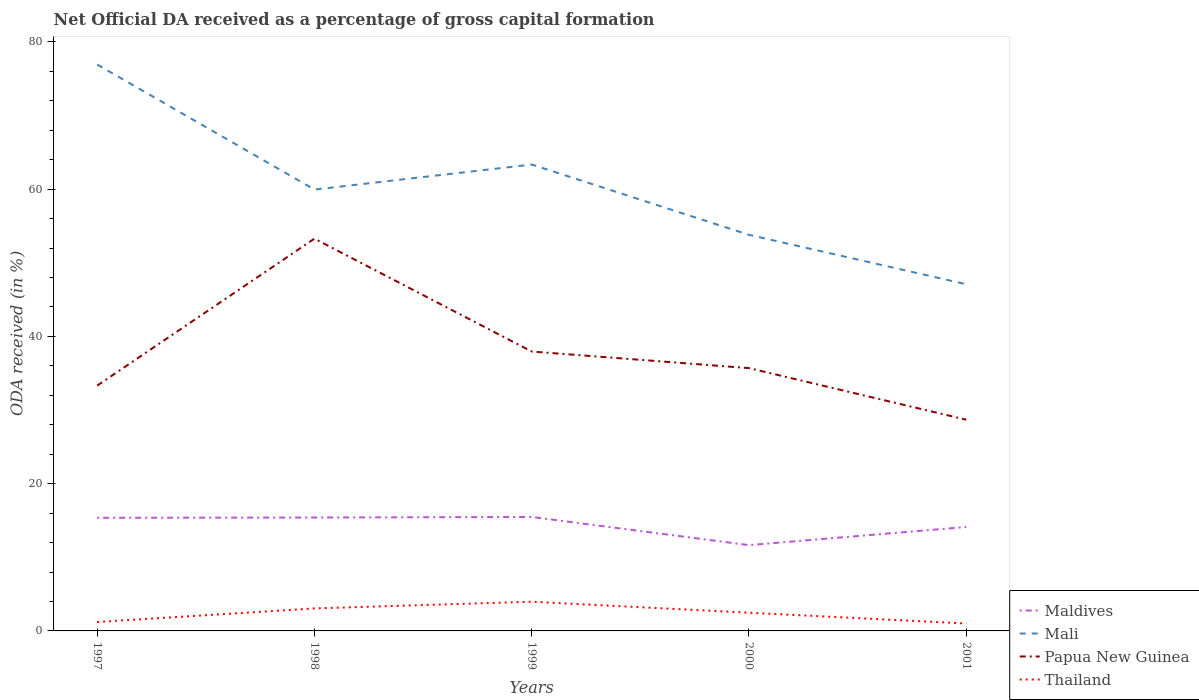Is the number of lines equal to the number of legend labels?
Give a very brief answer. Yes. Across all years, what is the maximum net ODA received in Papua New Guinea?
Your answer should be very brief. 28.69. In which year was the net ODA received in Thailand maximum?
Provide a short and direct response. 2001. What is the total net ODA received in Maldives in the graph?
Keep it short and to the point. -0.11. What is the difference between the highest and the second highest net ODA received in Thailand?
Offer a terse response. 2.96. What is the difference between two consecutive major ticks on the Y-axis?
Keep it short and to the point. 20. Are the values on the major ticks of Y-axis written in scientific E-notation?
Offer a very short reply. No. Where does the legend appear in the graph?
Offer a terse response. Bottom right. How are the legend labels stacked?
Your response must be concise. Vertical. What is the title of the graph?
Your answer should be very brief. Net Official DA received as a percentage of gross capital formation. What is the label or title of the X-axis?
Ensure brevity in your answer.  Years. What is the label or title of the Y-axis?
Your answer should be very brief. ODA received (in %). What is the ODA received (in %) in Maldives in 1997?
Provide a short and direct response. 15.37. What is the ODA received (in %) in Mali in 1997?
Make the answer very short. 76.93. What is the ODA received (in %) in Papua New Guinea in 1997?
Your answer should be compact. 33.32. What is the ODA received (in %) in Thailand in 1997?
Provide a succinct answer. 1.21. What is the ODA received (in %) of Maldives in 1998?
Provide a short and direct response. 15.4. What is the ODA received (in %) of Mali in 1998?
Offer a terse response. 59.95. What is the ODA received (in %) of Papua New Guinea in 1998?
Ensure brevity in your answer.  53.28. What is the ODA received (in %) of Thailand in 1998?
Offer a terse response. 3.06. What is the ODA received (in %) of Maldives in 1999?
Keep it short and to the point. 15.48. What is the ODA received (in %) of Mali in 1999?
Your answer should be very brief. 63.35. What is the ODA received (in %) in Papua New Guinea in 1999?
Offer a very short reply. 37.95. What is the ODA received (in %) of Thailand in 1999?
Give a very brief answer. 3.97. What is the ODA received (in %) of Maldives in 2000?
Keep it short and to the point. 11.65. What is the ODA received (in %) in Mali in 2000?
Offer a very short reply. 53.8. What is the ODA received (in %) in Papua New Guinea in 2000?
Give a very brief answer. 35.69. What is the ODA received (in %) of Thailand in 2000?
Ensure brevity in your answer.  2.47. What is the ODA received (in %) in Maldives in 2001?
Offer a very short reply. 14.12. What is the ODA received (in %) in Mali in 2001?
Your answer should be compact. 47.08. What is the ODA received (in %) in Papua New Guinea in 2001?
Your answer should be compact. 28.69. What is the ODA received (in %) in Thailand in 2001?
Your response must be concise. 1.01. Across all years, what is the maximum ODA received (in %) in Maldives?
Provide a short and direct response. 15.48. Across all years, what is the maximum ODA received (in %) of Mali?
Give a very brief answer. 76.93. Across all years, what is the maximum ODA received (in %) in Papua New Guinea?
Your response must be concise. 53.28. Across all years, what is the maximum ODA received (in %) of Thailand?
Offer a very short reply. 3.97. Across all years, what is the minimum ODA received (in %) of Maldives?
Make the answer very short. 11.65. Across all years, what is the minimum ODA received (in %) of Mali?
Your answer should be compact. 47.08. Across all years, what is the minimum ODA received (in %) in Papua New Guinea?
Your answer should be compact. 28.69. Across all years, what is the minimum ODA received (in %) in Thailand?
Ensure brevity in your answer.  1.01. What is the total ODA received (in %) of Maldives in the graph?
Ensure brevity in your answer.  72.01. What is the total ODA received (in %) of Mali in the graph?
Provide a succinct answer. 301.1. What is the total ODA received (in %) in Papua New Guinea in the graph?
Provide a succinct answer. 188.92. What is the total ODA received (in %) in Thailand in the graph?
Offer a terse response. 11.72. What is the difference between the ODA received (in %) in Maldives in 1997 and that in 1998?
Make the answer very short. -0.04. What is the difference between the ODA received (in %) in Mali in 1997 and that in 1998?
Your response must be concise. 16.98. What is the difference between the ODA received (in %) in Papua New Guinea in 1997 and that in 1998?
Your answer should be compact. -19.96. What is the difference between the ODA received (in %) of Thailand in 1997 and that in 1998?
Your response must be concise. -1.85. What is the difference between the ODA received (in %) in Maldives in 1997 and that in 1999?
Keep it short and to the point. -0.11. What is the difference between the ODA received (in %) in Mali in 1997 and that in 1999?
Give a very brief answer. 13.58. What is the difference between the ODA received (in %) in Papua New Guinea in 1997 and that in 1999?
Your answer should be very brief. -4.63. What is the difference between the ODA received (in %) of Thailand in 1997 and that in 1999?
Make the answer very short. -2.76. What is the difference between the ODA received (in %) in Maldives in 1997 and that in 2000?
Keep it short and to the point. 3.71. What is the difference between the ODA received (in %) in Mali in 1997 and that in 2000?
Your answer should be very brief. 23.13. What is the difference between the ODA received (in %) in Papua New Guinea in 1997 and that in 2000?
Your answer should be very brief. -2.37. What is the difference between the ODA received (in %) of Thailand in 1997 and that in 2000?
Provide a succinct answer. -1.26. What is the difference between the ODA received (in %) of Maldives in 1997 and that in 2001?
Provide a succinct answer. 1.25. What is the difference between the ODA received (in %) in Mali in 1997 and that in 2001?
Make the answer very short. 29.84. What is the difference between the ODA received (in %) in Papua New Guinea in 1997 and that in 2001?
Your answer should be very brief. 4.63. What is the difference between the ODA received (in %) in Thailand in 1997 and that in 2001?
Your response must be concise. 0.2. What is the difference between the ODA received (in %) in Maldives in 1998 and that in 1999?
Your response must be concise. -0.08. What is the difference between the ODA received (in %) of Papua New Guinea in 1998 and that in 1999?
Give a very brief answer. 15.33. What is the difference between the ODA received (in %) in Thailand in 1998 and that in 1999?
Your response must be concise. -0.91. What is the difference between the ODA received (in %) of Maldives in 1998 and that in 2000?
Provide a succinct answer. 3.75. What is the difference between the ODA received (in %) of Mali in 1998 and that in 2000?
Provide a succinct answer. 6.15. What is the difference between the ODA received (in %) in Papua New Guinea in 1998 and that in 2000?
Offer a very short reply. 17.58. What is the difference between the ODA received (in %) of Thailand in 1998 and that in 2000?
Offer a terse response. 0.59. What is the difference between the ODA received (in %) in Maldives in 1998 and that in 2001?
Offer a very short reply. 1.28. What is the difference between the ODA received (in %) in Mali in 1998 and that in 2001?
Your answer should be very brief. 12.86. What is the difference between the ODA received (in %) in Papua New Guinea in 1998 and that in 2001?
Provide a succinct answer. 24.59. What is the difference between the ODA received (in %) in Thailand in 1998 and that in 2001?
Offer a terse response. 2.05. What is the difference between the ODA received (in %) in Maldives in 1999 and that in 2000?
Keep it short and to the point. 3.83. What is the difference between the ODA received (in %) in Mali in 1999 and that in 2000?
Offer a very short reply. 9.55. What is the difference between the ODA received (in %) in Papua New Guinea in 1999 and that in 2000?
Your answer should be compact. 2.25. What is the difference between the ODA received (in %) in Thailand in 1999 and that in 2000?
Make the answer very short. 1.49. What is the difference between the ODA received (in %) in Maldives in 1999 and that in 2001?
Give a very brief answer. 1.36. What is the difference between the ODA received (in %) of Mali in 1999 and that in 2001?
Offer a terse response. 16.26. What is the difference between the ODA received (in %) in Papua New Guinea in 1999 and that in 2001?
Your response must be concise. 9.26. What is the difference between the ODA received (in %) in Thailand in 1999 and that in 2001?
Offer a terse response. 2.96. What is the difference between the ODA received (in %) of Maldives in 2000 and that in 2001?
Give a very brief answer. -2.46. What is the difference between the ODA received (in %) of Mali in 2000 and that in 2001?
Give a very brief answer. 6.71. What is the difference between the ODA received (in %) in Papua New Guinea in 2000 and that in 2001?
Your answer should be compact. 7.01. What is the difference between the ODA received (in %) of Thailand in 2000 and that in 2001?
Offer a terse response. 1.47. What is the difference between the ODA received (in %) of Maldives in 1997 and the ODA received (in %) of Mali in 1998?
Make the answer very short. -44.58. What is the difference between the ODA received (in %) of Maldives in 1997 and the ODA received (in %) of Papua New Guinea in 1998?
Keep it short and to the point. -37.91. What is the difference between the ODA received (in %) in Maldives in 1997 and the ODA received (in %) in Thailand in 1998?
Offer a very short reply. 12.31. What is the difference between the ODA received (in %) of Mali in 1997 and the ODA received (in %) of Papua New Guinea in 1998?
Offer a very short reply. 23.65. What is the difference between the ODA received (in %) of Mali in 1997 and the ODA received (in %) of Thailand in 1998?
Your answer should be very brief. 73.87. What is the difference between the ODA received (in %) in Papua New Guinea in 1997 and the ODA received (in %) in Thailand in 1998?
Give a very brief answer. 30.26. What is the difference between the ODA received (in %) in Maldives in 1997 and the ODA received (in %) in Mali in 1999?
Offer a terse response. -47.98. What is the difference between the ODA received (in %) in Maldives in 1997 and the ODA received (in %) in Papua New Guinea in 1999?
Give a very brief answer. -22.58. What is the difference between the ODA received (in %) of Maldives in 1997 and the ODA received (in %) of Thailand in 1999?
Your answer should be very brief. 11.4. What is the difference between the ODA received (in %) in Mali in 1997 and the ODA received (in %) in Papua New Guinea in 1999?
Provide a succinct answer. 38.98. What is the difference between the ODA received (in %) of Mali in 1997 and the ODA received (in %) of Thailand in 1999?
Keep it short and to the point. 72.96. What is the difference between the ODA received (in %) in Papua New Guinea in 1997 and the ODA received (in %) in Thailand in 1999?
Make the answer very short. 29.35. What is the difference between the ODA received (in %) of Maldives in 1997 and the ODA received (in %) of Mali in 2000?
Provide a succinct answer. -38.43. What is the difference between the ODA received (in %) of Maldives in 1997 and the ODA received (in %) of Papua New Guinea in 2000?
Ensure brevity in your answer.  -20.33. What is the difference between the ODA received (in %) in Maldives in 1997 and the ODA received (in %) in Thailand in 2000?
Offer a terse response. 12.89. What is the difference between the ODA received (in %) in Mali in 1997 and the ODA received (in %) in Papua New Guinea in 2000?
Your answer should be compact. 41.24. What is the difference between the ODA received (in %) of Mali in 1997 and the ODA received (in %) of Thailand in 2000?
Offer a very short reply. 74.45. What is the difference between the ODA received (in %) in Papua New Guinea in 1997 and the ODA received (in %) in Thailand in 2000?
Keep it short and to the point. 30.84. What is the difference between the ODA received (in %) in Maldives in 1997 and the ODA received (in %) in Mali in 2001?
Offer a very short reply. -31.72. What is the difference between the ODA received (in %) in Maldives in 1997 and the ODA received (in %) in Papua New Guinea in 2001?
Provide a succinct answer. -13.32. What is the difference between the ODA received (in %) in Maldives in 1997 and the ODA received (in %) in Thailand in 2001?
Give a very brief answer. 14.36. What is the difference between the ODA received (in %) of Mali in 1997 and the ODA received (in %) of Papua New Guinea in 2001?
Provide a short and direct response. 48.24. What is the difference between the ODA received (in %) in Mali in 1997 and the ODA received (in %) in Thailand in 2001?
Your answer should be very brief. 75.92. What is the difference between the ODA received (in %) of Papua New Guinea in 1997 and the ODA received (in %) of Thailand in 2001?
Your answer should be compact. 32.31. What is the difference between the ODA received (in %) in Maldives in 1998 and the ODA received (in %) in Mali in 1999?
Give a very brief answer. -47.94. What is the difference between the ODA received (in %) in Maldives in 1998 and the ODA received (in %) in Papua New Guinea in 1999?
Your answer should be compact. -22.55. What is the difference between the ODA received (in %) of Maldives in 1998 and the ODA received (in %) of Thailand in 1999?
Keep it short and to the point. 11.44. What is the difference between the ODA received (in %) of Mali in 1998 and the ODA received (in %) of Papua New Guinea in 1999?
Make the answer very short. 22. What is the difference between the ODA received (in %) in Mali in 1998 and the ODA received (in %) in Thailand in 1999?
Give a very brief answer. 55.98. What is the difference between the ODA received (in %) in Papua New Guinea in 1998 and the ODA received (in %) in Thailand in 1999?
Keep it short and to the point. 49.31. What is the difference between the ODA received (in %) in Maldives in 1998 and the ODA received (in %) in Mali in 2000?
Keep it short and to the point. -38.4. What is the difference between the ODA received (in %) in Maldives in 1998 and the ODA received (in %) in Papua New Guinea in 2000?
Give a very brief answer. -20.29. What is the difference between the ODA received (in %) in Maldives in 1998 and the ODA received (in %) in Thailand in 2000?
Provide a short and direct response. 12.93. What is the difference between the ODA received (in %) of Mali in 1998 and the ODA received (in %) of Papua New Guinea in 2000?
Ensure brevity in your answer.  24.25. What is the difference between the ODA received (in %) in Mali in 1998 and the ODA received (in %) in Thailand in 2000?
Your answer should be compact. 57.47. What is the difference between the ODA received (in %) in Papua New Guinea in 1998 and the ODA received (in %) in Thailand in 2000?
Your response must be concise. 50.8. What is the difference between the ODA received (in %) in Maldives in 1998 and the ODA received (in %) in Mali in 2001?
Offer a very short reply. -31.68. What is the difference between the ODA received (in %) in Maldives in 1998 and the ODA received (in %) in Papua New Guinea in 2001?
Your answer should be very brief. -13.28. What is the difference between the ODA received (in %) of Maldives in 1998 and the ODA received (in %) of Thailand in 2001?
Offer a very short reply. 14.39. What is the difference between the ODA received (in %) of Mali in 1998 and the ODA received (in %) of Papua New Guinea in 2001?
Your answer should be very brief. 31.26. What is the difference between the ODA received (in %) in Mali in 1998 and the ODA received (in %) in Thailand in 2001?
Offer a terse response. 58.94. What is the difference between the ODA received (in %) in Papua New Guinea in 1998 and the ODA received (in %) in Thailand in 2001?
Give a very brief answer. 52.27. What is the difference between the ODA received (in %) in Maldives in 1999 and the ODA received (in %) in Mali in 2000?
Your answer should be very brief. -38.32. What is the difference between the ODA received (in %) of Maldives in 1999 and the ODA received (in %) of Papua New Guinea in 2000?
Your answer should be compact. -20.21. What is the difference between the ODA received (in %) in Maldives in 1999 and the ODA received (in %) in Thailand in 2000?
Offer a very short reply. 13. What is the difference between the ODA received (in %) in Mali in 1999 and the ODA received (in %) in Papua New Guinea in 2000?
Your response must be concise. 27.65. What is the difference between the ODA received (in %) of Mali in 1999 and the ODA received (in %) of Thailand in 2000?
Your response must be concise. 60.87. What is the difference between the ODA received (in %) in Papua New Guinea in 1999 and the ODA received (in %) in Thailand in 2000?
Your response must be concise. 35.47. What is the difference between the ODA received (in %) of Maldives in 1999 and the ODA received (in %) of Mali in 2001?
Ensure brevity in your answer.  -31.61. What is the difference between the ODA received (in %) of Maldives in 1999 and the ODA received (in %) of Papua New Guinea in 2001?
Give a very brief answer. -13.21. What is the difference between the ODA received (in %) of Maldives in 1999 and the ODA received (in %) of Thailand in 2001?
Keep it short and to the point. 14.47. What is the difference between the ODA received (in %) of Mali in 1999 and the ODA received (in %) of Papua New Guinea in 2001?
Ensure brevity in your answer.  34.66. What is the difference between the ODA received (in %) in Mali in 1999 and the ODA received (in %) in Thailand in 2001?
Keep it short and to the point. 62.34. What is the difference between the ODA received (in %) of Papua New Guinea in 1999 and the ODA received (in %) of Thailand in 2001?
Make the answer very short. 36.94. What is the difference between the ODA received (in %) in Maldives in 2000 and the ODA received (in %) in Mali in 2001?
Offer a very short reply. -35.43. What is the difference between the ODA received (in %) of Maldives in 2000 and the ODA received (in %) of Papua New Guinea in 2001?
Your answer should be compact. -17.03. What is the difference between the ODA received (in %) of Maldives in 2000 and the ODA received (in %) of Thailand in 2001?
Provide a succinct answer. 10.64. What is the difference between the ODA received (in %) of Mali in 2000 and the ODA received (in %) of Papua New Guinea in 2001?
Provide a succinct answer. 25.11. What is the difference between the ODA received (in %) of Mali in 2000 and the ODA received (in %) of Thailand in 2001?
Your answer should be compact. 52.79. What is the difference between the ODA received (in %) of Papua New Guinea in 2000 and the ODA received (in %) of Thailand in 2001?
Offer a very short reply. 34.68. What is the average ODA received (in %) in Maldives per year?
Provide a succinct answer. 14.4. What is the average ODA received (in %) in Mali per year?
Your answer should be very brief. 60.22. What is the average ODA received (in %) in Papua New Guinea per year?
Provide a succinct answer. 37.78. What is the average ODA received (in %) of Thailand per year?
Your answer should be compact. 2.34. In the year 1997, what is the difference between the ODA received (in %) of Maldives and ODA received (in %) of Mali?
Give a very brief answer. -61.56. In the year 1997, what is the difference between the ODA received (in %) of Maldives and ODA received (in %) of Papua New Guinea?
Your answer should be compact. -17.95. In the year 1997, what is the difference between the ODA received (in %) of Maldives and ODA received (in %) of Thailand?
Make the answer very short. 14.15. In the year 1997, what is the difference between the ODA received (in %) of Mali and ODA received (in %) of Papua New Guinea?
Offer a very short reply. 43.61. In the year 1997, what is the difference between the ODA received (in %) of Mali and ODA received (in %) of Thailand?
Provide a succinct answer. 75.72. In the year 1997, what is the difference between the ODA received (in %) of Papua New Guinea and ODA received (in %) of Thailand?
Offer a very short reply. 32.11. In the year 1998, what is the difference between the ODA received (in %) of Maldives and ODA received (in %) of Mali?
Your answer should be very brief. -44.54. In the year 1998, what is the difference between the ODA received (in %) of Maldives and ODA received (in %) of Papua New Guinea?
Keep it short and to the point. -37.87. In the year 1998, what is the difference between the ODA received (in %) of Maldives and ODA received (in %) of Thailand?
Keep it short and to the point. 12.34. In the year 1998, what is the difference between the ODA received (in %) in Mali and ODA received (in %) in Papua New Guinea?
Your response must be concise. 6.67. In the year 1998, what is the difference between the ODA received (in %) in Mali and ODA received (in %) in Thailand?
Your response must be concise. 56.89. In the year 1998, what is the difference between the ODA received (in %) of Papua New Guinea and ODA received (in %) of Thailand?
Offer a terse response. 50.22. In the year 1999, what is the difference between the ODA received (in %) in Maldives and ODA received (in %) in Mali?
Provide a short and direct response. -47.87. In the year 1999, what is the difference between the ODA received (in %) in Maldives and ODA received (in %) in Papua New Guinea?
Offer a terse response. -22.47. In the year 1999, what is the difference between the ODA received (in %) of Maldives and ODA received (in %) of Thailand?
Your answer should be compact. 11.51. In the year 1999, what is the difference between the ODA received (in %) in Mali and ODA received (in %) in Papua New Guinea?
Provide a short and direct response. 25.4. In the year 1999, what is the difference between the ODA received (in %) of Mali and ODA received (in %) of Thailand?
Keep it short and to the point. 59.38. In the year 1999, what is the difference between the ODA received (in %) of Papua New Guinea and ODA received (in %) of Thailand?
Your answer should be very brief. 33.98. In the year 2000, what is the difference between the ODA received (in %) of Maldives and ODA received (in %) of Mali?
Give a very brief answer. -42.14. In the year 2000, what is the difference between the ODA received (in %) of Maldives and ODA received (in %) of Papua New Guinea?
Your answer should be very brief. -24.04. In the year 2000, what is the difference between the ODA received (in %) of Maldives and ODA received (in %) of Thailand?
Keep it short and to the point. 9.18. In the year 2000, what is the difference between the ODA received (in %) in Mali and ODA received (in %) in Papua New Guinea?
Offer a terse response. 18.1. In the year 2000, what is the difference between the ODA received (in %) in Mali and ODA received (in %) in Thailand?
Provide a succinct answer. 51.32. In the year 2000, what is the difference between the ODA received (in %) of Papua New Guinea and ODA received (in %) of Thailand?
Keep it short and to the point. 33.22. In the year 2001, what is the difference between the ODA received (in %) of Maldives and ODA received (in %) of Mali?
Offer a very short reply. -32.97. In the year 2001, what is the difference between the ODA received (in %) in Maldives and ODA received (in %) in Papua New Guinea?
Offer a terse response. -14.57. In the year 2001, what is the difference between the ODA received (in %) in Maldives and ODA received (in %) in Thailand?
Your answer should be compact. 13.11. In the year 2001, what is the difference between the ODA received (in %) in Mali and ODA received (in %) in Papua New Guinea?
Provide a succinct answer. 18.4. In the year 2001, what is the difference between the ODA received (in %) in Mali and ODA received (in %) in Thailand?
Give a very brief answer. 46.08. In the year 2001, what is the difference between the ODA received (in %) of Papua New Guinea and ODA received (in %) of Thailand?
Offer a very short reply. 27.68. What is the ratio of the ODA received (in %) in Maldives in 1997 to that in 1998?
Keep it short and to the point. 1. What is the ratio of the ODA received (in %) of Mali in 1997 to that in 1998?
Make the answer very short. 1.28. What is the ratio of the ODA received (in %) in Papua New Guinea in 1997 to that in 1998?
Your response must be concise. 0.63. What is the ratio of the ODA received (in %) of Thailand in 1997 to that in 1998?
Offer a very short reply. 0.4. What is the ratio of the ODA received (in %) of Maldives in 1997 to that in 1999?
Give a very brief answer. 0.99. What is the ratio of the ODA received (in %) in Mali in 1997 to that in 1999?
Your answer should be compact. 1.21. What is the ratio of the ODA received (in %) in Papua New Guinea in 1997 to that in 1999?
Keep it short and to the point. 0.88. What is the ratio of the ODA received (in %) of Thailand in 1997 to that in 1999?
Offer a very short reply. 0.31. What is the ratio of the ODA received (in %) in Maldives in 1997 to that in 2000?
Your response must be concise. 1.32. What is the ratio of the ODA received (in %) in Mali in 1997 to that in 2000?
Ensure brevity in your answer.  1.43. What is the ratio of the ODA received (in %) of Papua New Guinea in 1997 to that in 2000?
Ensure brevity in your answer.  0.93. What is the ratio of the ODA received (in %) in Thailand in 1997 to that in 2000?
Keep it short and to the point. 0.49. What is the ratio of the ODA received (in %) in Maldives in 1997 to that in 2001?
Ensure brevity in your answer.  1.09. What is the ratio of the ODA received (in %) in Mali in 1997 to that in 2001?
Offer a terse response. 1.63. What is the ratio of the ODA received (in %) of Papua New Guinea in 1997 to that in 2001?
Your answer should be compact. 1.16. What is the ratio of the ODA received (in %) in Thailand in 1997 to that in 2001?
Your response must be concise. 1.2. What is the ratio of the ODA received (in %) in Maldives in 1998 to that in 1999?
Keep it short and to the point. 1. What is the ratio of the ODA received (in %) of Mali in 1998 to that in 1999?
Give a very brief answer. 0.95. What is the ratio of the ODA received (in %) in Papua New Guinea in 1998 to that in 1999?
Give a very brief answer. 1.4. What is the ratio of the ODA received (in %) in Thailand in 1998 to that in 1999?
Provide a succinct answer. 0.77. What is the ratio of the ODA received (in %) in Maldives in 1998 to that in 2000?
Your response must be concise. 1.32. What is the ratio of the ODA received (in %) of Mali in 1998 to that in 2000?
Provide a succinct answer. 1.11. What is the ratio of the ODA received (in %) of Papua New Guinea in 1998 to that in 2000?
Your answer should be compact. 1.49. What is the ratio of the ODA received (in %) of Thailand in 1998 to that in 2000?
Provide a succinct answer. 1.24. What is the ratio of the ODA received (in %) in Maldives in 1998 to that in 2001?
Keep it short and to the point. 1.09. What is the ratio of the ODA received (in %) in Mali in 1998 to that in 2001?
Offer a terse response. 1.27. What is the ratio of the ODA received (in %) of Papua New Guinea in 1998 to that in 2001?
Provide a succinct answer. 1.86. What is the ratio of the ODA received (in %) in Thailand in 1998 to that in 2001?
Offer a terse response. 3.03. What is the ratio of the ODA received (in %) of Maldives in 1999 to that in 2000?
Give a very brief answer. 1.33. What is the ratio of the ODA received (in %) of Mali in 1999 to that in 2000?
Ensure brevity in your answer.  1.18. What is the ratio of the ODA received (in %) in Papua New Guinea in 1999 to that in 2000?
Give a very brief answer. 1.06. What is the ratio of the ODA received (in %) in Thailand in 1999 to that in 2000?
Your answer should be compact. 1.6. What is the ratio of the ODA received (in %) of Maldives in 1999 to that in 2001?
Give a very brief answer. 1.1. What is the ratio of the ODA received (in %) of Mali in 1999 to that in 2001?
Your answer should be very brief. 1.35. What is the ratio of the ODA received (in %) of Papua New Guinea in 1999 to that in 2001?
Your response must be concise. 1.32. What is the ratio of the ODA received (in %) of Thailand in 1999 to that in 2001?
Provide a short and direct response. 3.93. What is the ratio of the ODA received (in %) of Maldives in 2000 to that in 2001?
Your answer should be compact. 0.83. What is the ratio of the ODA received (in %) in Mali in 2000 to that in 2001?
Offer a terse response. 1.14. What is the ratio of the ODA received (in %) of Papua New Guinea in 2000 to that in 2001?
Offer a terse response. 1.24. What is the ratio of the ODA received (in %) in Thailand in 2000 to that in 2001?
Your answer should be compact. 2.45. What is the difference between the highest and the second highest ODA received (in %) of Maldives?
Offer a terse response. 0.08. What is the difference between the highest and the second highest ODA received (in %) of Mali?
Your answer should be very brief. 13.58. What is the difference between the highest and the second highest ODA received (in %) of Papua New Guinea?
Your answer should be very brief. 15.33. What is the difference between the highest and the second highest ODA received (in %) in Thailand?
Keep it short and to the point. 0.91. What is the difference between the highest and the lowest ODA received (in %) in Maldives?
Provide a short and direct response. 3.83. What is the difference between the highest and the lowest ODA received (in %) of Mali?
Make the answer very short. 29.84. What is the difference between the highest and the lowest ODA received (in %) in Papua New Guinea?
Offer a terse response. 24.59. What is the difference between the highest and the lowest ODA received (in %) of Thailand?
Offer a terse response. 2.96. 